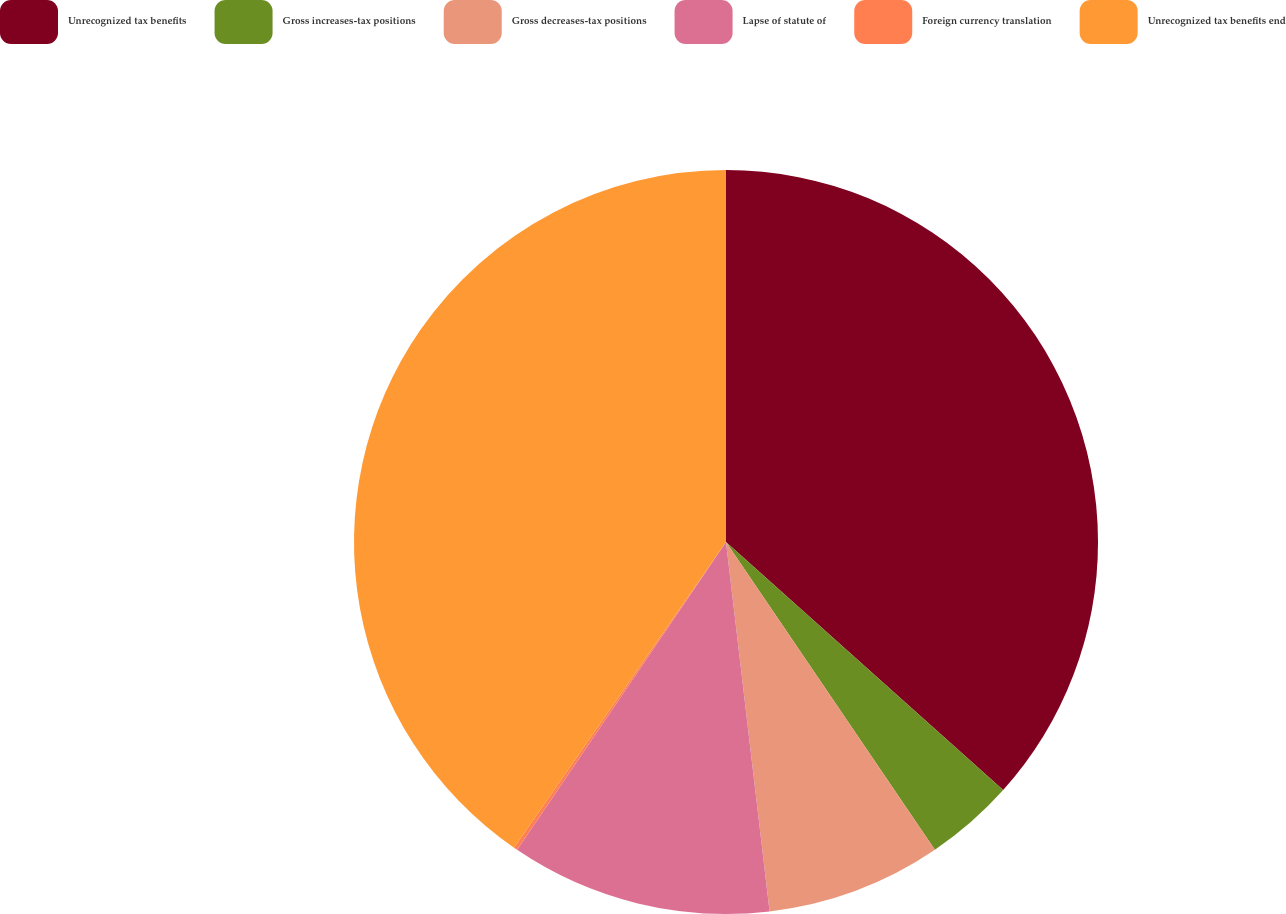Convert chart. <chart><loc_0><loc_0><loc_500><loc_500><pie_chart><fcel>Unrecognized tax benefits<fcel>Gross increases-tax positions<fcel>Gross decreases-tax positions<fcel>Lapse of statute of<fcel>Foreign currency translation<fcel>Unrecognized tax benefits end<nl><fcel>36.62%<fcel>3.89%<fcel>7.62%<fcel>11.36%<fcel>0.16%<fcel>40.35%<nl></chart> 